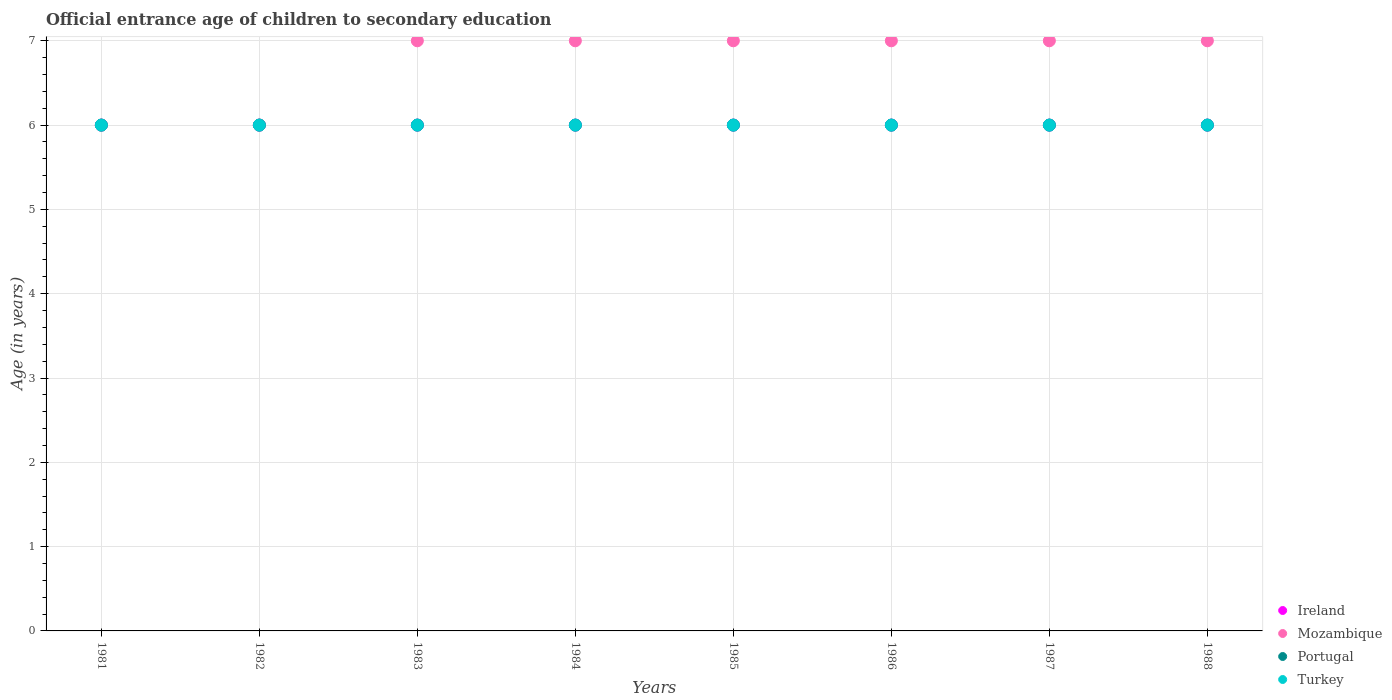How many different coloured dotlines are there?
Keep it short and to the point. 4. What is the secondary school starting age of children in Ireland in 1988?
Ensure brevity in your answer.  6. Across all years, what is the maximum secondary school starting age of children in Mozambique?
Your answer should be compact. 7. Across all years, what is the minimum secondary school starting age of children in Portugal?
Your answer should be very brief. 6. In which year was the secondary school starting age of children in Portugal maximum?
Your response must be concise. 1981. In which year was the secondary school starting age of children in Ireland minimum?
Keep it short and to the point. 1981. What is the total secondary school starting age of children in Mozambique in the graph?
Ensure brevity in your answer.  54. What is the average secondary school starting age of children in Mozambique per year?
Ensure brevity in your answer.  6.75. In the year 1986, what is the difference between the secondary school starting age of children in Mozambique and secondary school starting age of children in Ireland?
Offer a very short reply. 1. In how many years, is the secondary school starting age of children in Turkey greater than 6 years?
Your answer should be very brief. 0. What is the ratio of the secondary school starting age of children in Portugal in 1981 to that in 1984?
Your answer should be very brief. 1. Is the secondary school starting age of children in Portugal in 1984 less than that in 1985?
Your answer should be compact. No. Is the difference between the secondary school starting age of children in Mozambique in 1982 and 1987 greater than the difference between the secondary school starting age of children in Ireland in 1982 and 1987?
Your answer should be very brief. No. What is the difference between the highest and the second highest secondary school starting age of children in Mozambique?
Give a very brief answer. 0. What is the difference between the highest and the lowest secondary school starting age of children in Portugal?
Keep it short and to the point. 0. Is the sum of the secondary school starting age of children in Mozambique in 1982 and 1984 greater than the maximum secondary school starting age of children in Portugal across all years?
Your response must be concise. Yes. Is it the case that in every year, the sum of the secondary school starting age of children in Mozambique and secondary school starting age of children in Portugal  is greater than the sum of secondary school starting age of children in Ireland and secondary school starting age of children in Turkey?
Offer a terse response. No. Is it the case that in every year, the sum of the secondary school starting age of children in Portugal and secondary school starting age of children in Turkey  is greater than the secondary school starting age of children in Ireland?
Provide a succinct answer. Yes. What is the difference between two consecutive major ticks on the Y-axis?
Provide a succinct answer. 1. How many legend labels are there?
Provide a short and direct response. 4. What is the title of the graph?
Ensure brevity in your answer.  Official entrance age of children to secondary education. Does "Moldova" appear as one of the legend labels in the graph?
Ensure brevity in your answer.  No. What is the label or title of the X-axis?
Your answer should be very brief. Years. What is the label or title of the Y-axis?
Your response must be concise. Age (in years). What is the Age (in years) of Ireland in 1981?
Make the answer very short. 6. What is the Age (in years) in Turkey in 1981?
Make the answer very short. 6. What is the Age (in years) in Ireland in 1982?
Offer a terse response. 6. What is the Age (in years) in Mozambique in 1982?
Your response must be concise. 6. What is the Age (in years) of Portugal in 1982?
Ensure brevity in your answer.  6. What is the Age (in years) in Turkey in 1982?
Provide a short and direct response. 6. What is the Age (in years) in Ireland in 1983?
Offer a very short reply. 6. What is the Age (in years) in Mozambique in 1983?
Ensure brevity in your answer.  7. What is the Age (in years) in Portugal in 1983?
Make the answer very short. 6. What is the Age (in years) of Mozambique in 1984?
Provide a short and direct response. 7. What is the Age (in years) of Ireland in 1985?
Make the answer very short. 6. What is the Age (in years) in Mozambique in 1985?
Give a very brief answer. 7. What is the Age (in years) of Portugal in 1985?
Keep it short and to the point. 6. What is the Age (in years) in Turkey in 1985?
Provide a succinct answer. 6. What is the Age (in years) in Mozambique in 1986?
Your answer should be compact. 7. What is the Age (in years) in Turkey in 1986?
Give a very brief answer. 6. What is the Age (in years) in Portugal in 1987?
Provide a short and direct response. 6. What is the Age (in years) in Portugal in 1988?
Offer a very short reply. 6. What is the Age (in years) of Turkey in 1988?
Provide a succinct answer. 6. Across all years, what is the maximum Age (in years) in Portugal?
Ensure brevity in your answer.  6. Across all years, what is the minimum Age (in years) of Portugal?
Ensure brevity in your answer.  6. Across all years, what is the minimum Age (in years) in Turkey?
Offer a terse response. 6. What is the total Age (in years) of Ireland in the graph?
Your answer should be compact. 48. What is the total Age (in years) in Mozambique in the graph?
Keep it short and to the point. 54. What is the total Age (in years) in Portugal in the graph?
Your answer should be compact. 48. What is the difference between the Age (in years) of Ireland in 1981 and that in 1982?
Your answer should be very brief. 0. What is the difference between the Age (in years) of Mozambique in 1981 and that in 1982?
Offer a terse response. 0. What is the difference between the Age (in years) of Portugal in 1981 and that in 1982?
Your response must be concise. 0. What is the difference between the Age (in years) in Ireland in 1981 and that in 1983?
Keep it short and to the point. 0. What is the difference between the Age (in years) of Portugal in 1981 and that in 1983?
Your answer should be compact. 0. What is the difference between the Age (in years) of Turkey in 1981 and that in 1983?
Your answer should be very brief. 0. What is the difference between the Age (in years) of Ireland in 1981 and that in 1984?
Offer a very short reply. 0. What is the difference between the Age (in years) of Mozambique in 1981 and that in 1984?
Provide a short and direct response. -1. What is the difference between the Age (in years) in Portugal in 1981 and that in 1984?
Make the answer very short. 0. What is the difference between the Age (in years) in Mozambique in 1981 and that in 1985?
Offer a terse response. -1. What is the difference between the Age (in years) of Turkey in 1981 and that in 1985?
Your answer should be compact. 0. What is the difference between the Age (in years) of Ireland in 1981 and that in 1987?
Your answer should be compact. 0. What is the difference between the Age (in years) in Turkey in 1981 and that in 1987?
Ensure brevity in your answer.  0. What is the difference between the Age (in years) in Mozambique in 1981 and that in 1988?
Offer a terse response. -1. What is the difference between the Age (in years) of Ireland in 1982 and that in 1983?
Give a very brief answer. 0. What is the difference between the Age (in years) of Portugal in 1982 and that in 1983?
Your response must be concise. 0. What is the difference between the Age (in years) in Ireland in 1982 and that in 1984?
Make the answer very short. 0. What is the difference between the Age (in years) of Portugal in 1982 and that in 1984?
Make the answer very short. 0. What is the difference between the Age (in years) in Turkey in 1982 and that in 1984?
Keep it short and to the point. 0. What is the difference between the Age (in years) in Ireland in 1982 and that in 1985?
Ensure brevity in your answer.  0. What is the difference between the Age (in years) in Mozambique in 1982 and that in 1985?
Provide a succinct answer. -1. What is the difference between the Age (in years) of Portugal in 1982 and that in 1986?
Provide a succinct answer. 0. What is the difference between the Age (in years) in Mozambique in 1982 and that in 1987?
Your answer should be compact. -1. What is the difference between the Age (in years) in Turkey in 1982 and that in 1988?
Provide a succinct answer. 0. What is the difference between the Age (in years) of Ireland in 1983 and that in 1984?
Your answer should be very brief. 0. What is the difference between the Age (in years) in Turkey in 1983 and that in 1984?
Offer a terse response. 0. What is the difference between the Age (in years) in Portugal in 1983 and that in 1985?
Provide a short and direct response. 0. What is the difference between the Age (in years) in Ireland in 1983 and that in 1986?
Give a very brief answer. 0. What is the difference between the Age (in years) in Mozambique in 1983 and that in 1986?
Give a very brief answer. 0. What is the difference between the Age (in years) in Turkey in 1983 and that in 1986?
Your response must be concise. 0. What is the difference between the Age (in years) of Mozambique in 1983 and that in 1987?
Your response must be concise. 0. What is the difference between the Age (in years) of Portugal in 1983 and that in 1987?
Keep it short and to the point. 0. What is the difference between the Age (in years) in Turkey in 1983 and that in 1987?
Offer a terse response. 0. What is the difference between the Age (in years) in Ireland in 1983 and that in 1988?
Give a very brief answer. 0. What is the difference between the Age (in years) in Mozambique in 1983 and that in 1988?
Make the answer very short. 0. What is the difference between the Age (in years) in Ireland in 1984 and that in 1985?
Your response must be concise. 0. What is the difference between the Age (in years) in Ireland in 1984 and that in 1986?
Give a very brief answer. 0. What is the difference between the Age (in years) of Mozambique in 1984 and that in 1986?
Give a very brief answer. 0. What is the difference between the Age (in years) of Turkey in 1984 and that in 1986?
Offer a very short reply. 0. What is the difference between the Age (in years) of Turkey in 1984 and that in 1987?
Offer a very short reply. 0. What is the difference between the Age (in years) of Ireland in 1984 and that in 1988?
Your answer should be very brief. 0. What is the difference between the Age (in years) in Mozambique in 1984 and that in 1988?
Provide a short and direct response. 0. What is the difference between the Age (in years) in Portugal in 1984 and that in 1988?
Your answer should be very brief. 0. What is the difference between the Age (in years) in Ireland in 1985 and that in 1986?
Offer a very short reply. 0. What is the difference between the Age (in years) in Mozambique in 1985 and that in 1986?
Give a very brief answer. 0. What is the difference between the Age (in years) in Portugal in 1985 and that in 1986?
Provide a short and direct response. 0. What is the difference between the Age (in years) in Turkey in 1985 and that in 1986?
Your response must be concise. 0. What is the difference between the Age (in years) of Portugal in 1985 and that in 1987?
Make the answer very short. 0. What is the difference between the Age (in years) in Turkey in 1985 and that in 1987?
Offer a very short reply. 0. What is the difference between the Age (in years) in Ireland in 1985 and that in 1988?
Provide a short and direct response. 0. What is the difference between the Age (in years) in Turkey in 1985 and that in 1988?
Your response must be concise. 0. What is the difference between the Age (in years) in Portugal in 1986 and that in 1987?
Your answer should be compact. 0. What is the difference between the Age (in years) in Turkey in 1986 and that in 1987?
Your answer should be compact. 0. What is the difference between the Age (in years) of Ireland in 1986 and that in 1988?
Ensure brevity in your answer.  0. What is the difference between the Age (in years) in Mozambique in 1986 and that in 1988?
Your answer should be compact. 0. What is the difference between the Age (in years) of Portugal in 1986 and that in 1988?
Offer a very short reply. 0. What is the difference between the Age (in years) in Turkey in 1986 and that in 1988?
Your answer should be compact. 0. What is the difference between the Age (in years) in Turkey in 1987 and that in 1988?
Provide a short and direct response. 0. What is the difference between the Age (in years) in Ireland in 1981 and the Age (in years) in Portugal in 1982?
Provide a short and direct response. 0. What is the difference between the Age (in years) in Ireland in 1981 and the Age (in years) in Turkey in 1982?
Give a very brief answer. 0. What is the difference between the Age (in years) in Mozambique in 1981 and the Age (in years) in Turkey in 1982?
Keep it short and to the point. 0. What is the difference between the Age (in years) in Ireland in 1981 and the Age (in years) in Mozambique in 1983?
Make the answer very short. -1. What is the difference between the Age (in years) of Ireland in 1981 and the Age (in years) of Turkey in 1983?
Your answer should be very brief. 0. What is the difference between the Age (in years) of Mozambique in 1981 and the Age (in years) of Turkey in 1983?
Provide a short and direct response. 0. What is the difference between the Age (in years) in Ireland in 1981 and the Age (in years) in Mozambique in 1984?
Provide a succinct answer. -1. What is the difference between the Age (in years) of Ireland in 1981 and the Age (in years) of Portugal in 1984?
Provide a short and direct response. 0. What is the difference between the Age (in years) of Ireland in 1981 and the Age (in years) of Mozambique in 1985?
Your answer should be very brief. -1. What is the difference between the Age (in years) of Ireland in 1981 and the Age (in years) of Portugal in 1985?
Your answer should be very brief. 0. What is the difference between the Age (in years) of Ireland in 1981 and the Age (in years) of Turkey in 1985?
Keep it short and to the point. 0. What is the difference between the Age (in years) of Mozambique in 1981 and the Age (in years) of Turkey in 1985?
Your answer should be very brief. 0. What is the difference between the Age (in years) of Portugal in 1981 and the Age (in years) of Turkey in 1985?
Provide a succinct answer. 0. What is the difference between the Age (in years) of Ireland in 1981 and the Age (in years) of Mozambique in 1986?
Give a very brief answer. -1. What is the difference between the Age (in years) of Ireland in 1981 and the Age (in years) of Turkey in 1986?
Offer a terse response. 0. What is the difference between the Age (in years) in Portugal in 1981 and the Age (in years) in Turkey in 1986?
Your answer should be very brief. 0. What is the difference between the Age (in years) of Ireland in 1981 and the Age (in years) of Portugal in 1987?
Give a very brief answer. 0. What is the difference between the Age (in years) of Ireland in 1981 and the Age (in years) of Turkey in 1987?
Give a very brief answer. 0. What is the difference between the Age (in years) of Mozambique in 1981 and the Age (in years) of Portugal in 1987?
Your answer should be very brief. 0. What is the difference between the Age (in years) of Mozambique in 1981 and the Age (in years) of Turkey in 1987?
Your answer should be very brief. 0. What is the difference between the Age (in years) in Ireland in 1981 and the Age (in years) in Portugal in 1988?
Offer a terse response. 0. What is the difference between the Age (in years) of Ireland in 1981 and the Age (in years) of Turkey in 1988?
Your answer should be very brief. 0. What is the difference between the Age (in years) in Mozambique in 1981 and the Age (in years) in Turkey in 1988?
Provide a succinct answer. 0. What is the difference between the Age (in years) of Ireland in 1982 and the Age (in years) of Turkey in 1983?
Your answer should be very brief. 0. What is the difference between the Age (in years) of Mozambique in 1982 and the Age (in years) of Portugal in 1983?
Give a very brief answer. 0. What is the difference between the Age (in years) of Portugal in 1982 and the Age (in years) of Turkey in 1983?
Keep it short and to the point. 0. What is the difference between the Age (in years) of Ireland in 1982 and the Age (in years) of Turkey in 1984?
Ensure brevity in your answer.  0. What is the difference between the Age (in years) in Ireland in 1982 and the Age (in years) in Mozambique in 1985?
Make the answer very short. -1. What is the difference between the Age (in years) in Ireland in 1982 and the Age (in years) in Turkey in 1985?
Ensure brevity in your answer.  0. What is the difference between the Age (in years) in Mozambique in 1982 and the Age (in years) in Portugal in 1985?
Your answer should be very brief. 0. What is the difference between the Age (in years) of Mozambique in 1982 and the Age (in years) of Turkey in 1985?
Make the answer very short. 0. What is the difference between the Age (in years) in Ireland in 1982 and the Age (in years) in Mozambique in 1986?
Your answer should be compact. -1. What is the difference between the Age (in years) of Ireland in 1982 and the Age (in years) of Portugal in 1986?
Your answer should be compact. 0. What is the difference between the Age (in years) of Ireland in 1982 and the Age (in years) of Turkey in 1986?
Provide a short and direct response. 0. What is the difference between the Age (in years) of Ireland in 1982 and the Age (in years) of Portugal in 1987?
Give a very brief answer. 0. What is the difference between the Age (in years) of Mozambique in 1982 and the Age (in years) of Turkey in 1987?
Provide a short and direct response. 0. What is the difference between the Age (in years) of Ireland in 1982 and the Age (in years) of Portugal in 1988?
Ensure brevity in your answer.  0. What is the difference between the Age (in years) in Ireland in 1982 and the Age (in years) in Turkey in 1988?
Offer a very short reply. 0. What is the difference between the Age (in years) in Mozambique in 1982 and the Age (in years) in Portugal in 1988?
Provide a short and direct response. 0. What is the difference between the Age (in years) of Mozambique in 1982 and the Age (in years) of Turkey in 1988?
Your answer should be very brief. 0. What is the difference between the Age (in years) in Ireland in 1983 and the Age (in years) in Mozambique in 1984?
Provide a short and direct response. -1. What is the difference between the Age (in years) of Mozambique in 1983 and the Age (in years) of Portugal in 1984?
Keep it short and to the point. 1. What is the difference between the Age (in years) in Portugal in 1983 and the Age (in years) in Turkey in 1984?
Your response must be concise. 0. What is the difference between the Age (in years) of Mozambique in 1983 and the Age (in years) of Portugal in 1985?
Offer a very short reply. 1. What is the difference between the Age (in years) of Ireland in 1983 and the Age (in years) of Mozambique in 1986?
Keep it short and to the point. -1. What is the difference between the Age (in years) of Ireland in 1983 and the Age (in years) of Portugal in 1986?
Offer a terse response. 0. What is the difference between the Age (in years) in Mozambique in 1983 and the Age (in years) in Portugal in 1986?
Your answer should be compact. 1. What is the difference between the Age (in years) of Mozambique in 1983 and the Age (in years) of Turkey in 1986?
Keep it short and to the point. 1. What is the difference between the Age (in years) of Portugal in 1983 and the Age (in years) of Turkey in 1986?
Your response must be concise. 0. What is the difference between the Age (in years) of Ireland in 1983 and the Age (in years) of Portugal in 1987?
Your response must be concise. 0. What is the difference between the Age (in years) in Ireland in 1983 and the Age (in years) in Turkey in 1987?
Give a very brief answer. 0. What is the difference between the Age (in years) in Ireland in 1983 and the Age (in years) in Mozambique in 1988?
Provide a short and direct response. -1. What is the difference between the Age (in years) of Mozambique in 1983 and the Age (in years) of Turkey in 1988?
Make the answer very short. 1. What is the difference between the Age (in years) in Ireland in 1984 and the Age (in years) in Mozambique in 1985?
Offer a terse response. -1. What is the difference between the Age (in years) in Ireland in 1984 and the Age (in years) in Turkey in 1985?
Provide a short and direct response. 0. What is the difference between the Age (in years) in Mozambique in 1984 and the Age (in years) in Turkey in 1985?
Your answer should be compact. 1. What is the difference between the Age (in years) in Portugal in 1984 and the Age (in years) in Turkey in 1985?
Provide a short and direct response. 0. What is the difference between the Age (in years) in Ireland in 1984 and the Age (in years) in Portugal in 1986?
Keep it short and to the point. 0. What is the difference between the Age (in years) in Mozambique in 1984 and the Age (in years) in Portugal in 1986?
Your response must be concise. 1. What is the difference between the Age (in years) in Ireland in 1984 and the Age (in years) in Mozambique in 1987?
Your response must be concise. -1. What is the difference between the Age (in years) of Ireland in 1984 and the Age (in years) of Turkey in 1987?
Provide a succinct answer. 0. What is the difference between the Age (in years) in Portugal in 1984 and the Age (in years) in Turkey in 1987?
Offer a terse response. 0. What is the difference between the Age (in years) of Mozambique in 1984 and the Age (in years) of Turkey in 1988?
Offer a very short reply. 1. What is the difference between the Age (in years) in Ireland in 1985 and the Age (in years) in Mozambique in 1986?
Your answer should be very brief. -1. What is the difference between the Age (in years) in Ireland in 1985 and the Age (in years) in Portugal in 1986?
Offer a very short reply. 0. What is the difference between the Age (in years) of Mozambique in 1985 and the Age (in years) of Portugal in 1986?
Ensure brevity in your answer.  1. What is the difference between the Age (in years) of Mozambique in 1985 and the Age (in years) of Turkey in 1986?
Offer a terse response. 1. What is the difference between the Age (in years) in Portugal in 1985 and the Age (in years) in Turkey in 1986?
Provide a succinct answer. 0. What is the difference between the Age (in years) in Ireland in 1985 and the Age (in years) in Portugal in 1987?
Make the answer very short. 0. What is the difference between the Age (in years) of Ireland in 1985 and the Age (in years) of Turkey in 1987?
Provide a short and direct response. 0. What is the difference between the Age (in years) in Mozambique in 1985 and the Age (in years) in Portugal in 1987?
Your response must be concise. 1. What is the difference between the Age (in years) of Portugal in 1985 and the Age (in years) of Turkey in 1987?
Provide a succinct answer. 0. What is the difference between the Age (in years) in Mozambique in 1985 and the Age (in years) in Turkey in 1988?
Ensure brevity in your answer.  1. What is the difference between the Age (in years) in Portugal in 1985 and the Age (in years) in Turkey in 1988?
Make the answer very short. 0. What is the difference between the Age (in years) in Ireland in 1986 and the Age (in years) in Mozambique in 1987?
Keep it short and to the point. -1. What is the difference between the Age (in years) in Ireland in 1986 and the Age (in years) in Portugal in 1987?
Provide a short and direct response. 0. What is the difference between the Age (in years) in Mozambique in 1986 and the Age (in years) in Turkey in 1987?
Your response must be concise. 1. What is the difference between the Age (in years) in Ireland in 1986 and the Age (in years) in Mozambique in 1988?
Offer a very short reply. -1. What is the difference between the Age (in years) in Ireland in 1986 and the Age (in years) in Portugal in 1988?
Give a very brief answer. 0. What is the difference between the Age (in years) of Ireland in 1986 and the Age (in years) of Turkey in 1988?
Make the answer very short. 0. What is the difference between the Age (in years) in Mozambique in 1986 and the Age (in years) in Turkey in 1988?
Ensure brevity in your answer.  1. What is the difference between the Age (in years) in Portugal in 1986 and the Age (in years) in Turkey in 1988?
Ensure brevity in your answer.  0. What is the difference between the Age (in years) of Ireland in 1987 and the Age (in years) of Portugal in 1988?
Keep it short and to the point. 0. What is the difference between the Age (in years) of Ireland in 1987 and the Age (in years) of Turkey in 1988?
Your answer should be compact. 0. What is the difference between the Age (in years) of Mozambique in 1987 and the Age (in years) of Portugal in 1988?
Keep it short and to the point. 1. What is the difference between the Age (in years) in Portugal in 1987 and the Age (in years) in Turkey in 1988?
Your answer should be compact. 0. What is the average Age (in years) of Ireland per year?
Offer a very short reply. 6. What is the average Age (in years) of Mozambique per year?
Make the answer very short. 6.75. In the year 1981, what is the difference between the Age (in years) of Ireland and Age (in years) of Mozambique?
Offer a very short reply. 0. In the year 1981, what is the difference between the Age (in years) in Mozambique and Age (in years) in Portugal?
Provide a short and direct response. 0. In the year 1981, what is the difference between the Age (in years) of Portugal and Age (in years) of Turkey?
Your answer should be very brief. 0. In the year 1982, what is the difference between the Age (in years) of Ireland and Age (in years) of Mozambique?
Offer a terse response. 0. In the year 1982, what is the difference between the Age (in years) in Ireland and Age (in years) in Portugal?
Keep it short and to the point. 0. In the year 1982, what is the difference between the Age (in years) in Ireland and Age (in years) in Turkey?
Give a very brief answer. 0. In the year 1982, what is the difference between the Age (in years) of Mozambique and Age (in years) of Portugal?
Your answer should be compact. 0. In the year 1982, what is the difference between the Age (in years) of Portugal and Age (in years) of Turkey?
Your answer should be very brief. 0. In the year 1983, what is the difference between the Age (in years) of Ireland and Age (in years) of Portugal?
Your answer should be very brief. 0. In the year 1983, what is the difference between the Age (in years) of Ireland and Age (in years) of Turkey?
Ensure brevity in your answer.  0. In the year 1983, what is the difference between the Age (in years) in Mozambique and Age (in years) in Turkey?
Keep it short and to the point. 1. In the year 1983, what is the difference between the Age (in years) in Portugal and Age (in years) in Turkey?
Give a very brief answer. 0. In the year 1984, what is the difference between the Age (in years) of Ireland and Age (in years) of Mozambique?
Your answer should be compact. -1. In the year 1984, what is the difference between the Age (in years) in Ireland and Age (in years) in Turkey?
Give a very brief answer. 0. In the year 1985, what is the difference between the Age (in years) of Ireland and Age (in years) of Portugal?
Ensure brevity in your answer.  0. In the year 1985, what is the difference between the Age (in years) in Mozambique and Age (in years) in Portugal?
Give a very brief answer. 1. In the year 1985, what is the difference between the Age (in years) of Mozambique and Age (in years) of Turkey?
Your answer should be very brief. 1. In the year 1986, what is the difference between the Age (in years) in Portugal and Age (in years) in Turkey?
Your response must be concise. 0. In the year 1987, what is the difference between the Age (in years) in Ireland and Age (in years) in Mozambique?
Ensure brevity in your answer.  -1. In the year 1987, what is the difference between the Age (in years) in Ireland and Age (in years) in Portugal?
Ensure brevity in your answer.  0. In the year 1987, what is the difference between the Age (in years) of Ireland and Age (in years) of Turkey?
Provide a short and direct response. 0. In the year 1987, what is the difference between the Age (in years) of Mozambique and Age (in years) of Portugal?
Keep it short and to the point. 1. In the year 1987, what is the difference between the Age (in years) of Mozambique and Age (in years) of Turkey?
Offer a terse response. 1. In the year 1987, what is the difference between the Age (in years) in Portugal and Age (in years) in Turkey?
Offer a very short reply. 0. In the year 1988, what is the difference between the Age (in years) of Ireland and Age (in years) of Turkey?
Provide a succinct answer. 0. In the year 1988, what is the difference between the Age (in years) in Mozambique and Age (in years) in Portugal?
Provide a succinct answer. 1. In the year 1988, what is the difference between the Age (in years) of Mozambique and Age (in years) of Turkey?
Offer a terse response. 1. In the year 1988, what is the difference between the Age (in years) of Portugal and Age (in years) of Turkey?
Your answer should be very brief. 0. What is the ratio of the Age (in years) in Ireland in 1981 to that in 1983?
Your answer should be compact. 1. What is the ratio of the Age (in years) in Ireland in 1981 to that in 1984?
Your answer should be compact. 1. What is the ratio of the Age (in years) in Portugal in 1981 to that in 1984?
Your answer should be very brief. 1. What is the ratio of the Age (in years) in Ireland in 1981 to that in 1985?
Provide a short and direct response. 1. What is the ratio of the Age (in years) in Mozambique in 1981 to that in 1985?
Provide a succinct answer. 0.86. What is the ratio of the Age (in years) of Portugal in 1981 to that in 1985?
Give a very brief answer. 1. What is the ratio of the Age (in years) of Turkey in 1981 to that in 1985?
Your answer should be very brief. 1. What is the ratio of the Age (in years) in Ireland in 1981 to that in 1987?
Your answer should be compact. 1. What is the ratio of the Age (in years) of Turkey in 1981 to that in 1987?
Keep it short and to the point. 1. What is the ratio of the Age (in years) in Turkey in 1981 to that in 1988?
Make the answer very short. 1. What is the ratio of the Age (in years) of Ireland in 1982 to that in 1983?
Your response must be concise. 1. What is the ratio of the Age (in years) in Turkey in 1982 to that in 1983?
Your answer should be compact. 1. What is the ratio of the Age (in years) of Turkey in 1982 to that in 1984?
Your response must be concise. 1. What is the ratio of the Age (in years) in Ireland in 1982 to that in 1986?
Offer a terse response. 1. What is the ratio of the Age (in years) in Turkey in 1982 to that in 1986?
Keep it short and to the point. 1. What is the ratio of the Age (in years) of Ireland in 1982 to that in 1987?
Make the answer very short. 1. What is the ratio of the Age (in years) of Mozambique in 1982 to that in 1987?
Provide a short and direct response. 0.86. What is the ratio of the Age (in years) of Ireland in 1982 to that in 1988?
Provide a short and direct response. 1. What is the ratio of the Age (in years) in Mozambique in 1982 to that in 1988?
Your answer should be compact. 0.86. What is the ratio of the Age (in years) of Turkey in 1982 to that in 1988?
Provide a short and direct response. 1. What is the ratio of the Age (in years) in Ireland in 1983 to that in 1984?
Make the answer very short. 1. What is the ratio of the Age (in years) in Turkey in 1983 to that in 1984?
Ensure brevity in your answer.  1. What is the ratio of the Age (in years) of Mozambique in 1983 to that in 1985?
Provide a short and direct response. 1. What is the ratio of the Age (in years) in Ireland in 1983 to that in 1986?
Your answer should be very brief. 1. What is the ratio of the Age (in years) of Mozambique in 1983 to that in 1986?
Your response must be concise. 1. What is the ratio of the Age (in years) in Ireland in 1983 to that in 1987?
Give a very brief answer. 1. What is the ratio of the Age (in years) in Portugal in 1983 to that in 1987?
Your response must be concise. 1. What is the ratio of the Age (in years) in Turkey in 1983 to that in 1987?
Offer a terse response. 1. What is the ratio of the Age (in years) of Portugal in 1983 to that in 1988?
Offer a terse response. 1. What is the ratio of the Age (in years) in Mozambique in 1984 to that in 1985?
Your answer should be very brief. 1. What is the ratio of the Age (in years) in Portugal in 1984 to that in 1985?
Your answer should be compact. 1. What is the ratio of the Age (in years) in Ireland in 1984 to that in 1986?
Offer a very short reply. 1. What is the ratio of the Age (in years) in Portugal in 1984 to that in 1986?
Your response must be concise. 1. What is the ratio of the Age (in years) of Mozambique in 1984 to that in 1987?
Ensure brevity in your answer.  1. What is the ratio of the Age (in years) of Portugal in 1984 to that in 1987?
Give a very brief answer. 1. What is the ratio of the Age (in years) in Mozambique in 1984 to that in 1988?
Provide a short and direct response. 1. What is the ratio of the Age (in years) in Ireland in 1985 to that in 1986?
Your response must be concise. 1. What is the ratio of the Age (in years) in Mozambique in 1985 to that in 1986?
Your answer should be compact. 1. What is the ratio of the Age (in years) of Portugal in 1985 to that in 1986?
Give a very brief answer. 1. What is the ratio of the Age (in years) in Ireland in 1985 to that in 1987?
Provide a short and direct response. 1. What is the ratio of the Age (in years) of Portugal in 1985 to that in 1987?
Your answer should be compact. 1. What is the ratio of the Age (in years) of Mozambique in 1985 to that in 1988?
Offer a very short reply. 1. What is the ratio of the Age (in years) of Portugal in 1986 to that in 1987?
Offer a terse response. 1. What is the ratio of the Age (in years) in Turkey in 1986 to that in 1987?
Provide a succinct answer. 1. What is the ratio of the Age (in years) in Mozambique in 1986 to that in 1988?
Provide a succinct answer. 1. What is the ratio of the Age (in years) of Portugal in 1986 to that in 1988?
Make the answer very short. 1. What is the ratio of the Age (in years) in Turkey in 1986 to that in 1988?
Make the answer very short. 1. What is the ratio of the Age (in years) of Turkey in 1987 to that in 1988?
Offer a terse response. 1. What is the difference between the highest and the second highest Age (in years) of Ireland?
Make the answer very short. 0. What is the difference between the highest and the second highest Age (in years) in Mozambique?
Offer a terse response. 0. What is the difference between the highest and the second highest Age (in years) in Portugal?
Provide a short and direct response. 0. What is the difference between the highest and the lowest Age (in years) in Ireland?
Make the answer very short. 0. What is the difference between the highest and the lowest Age (in years) in Turkey?
Make the answer very short. 0. 